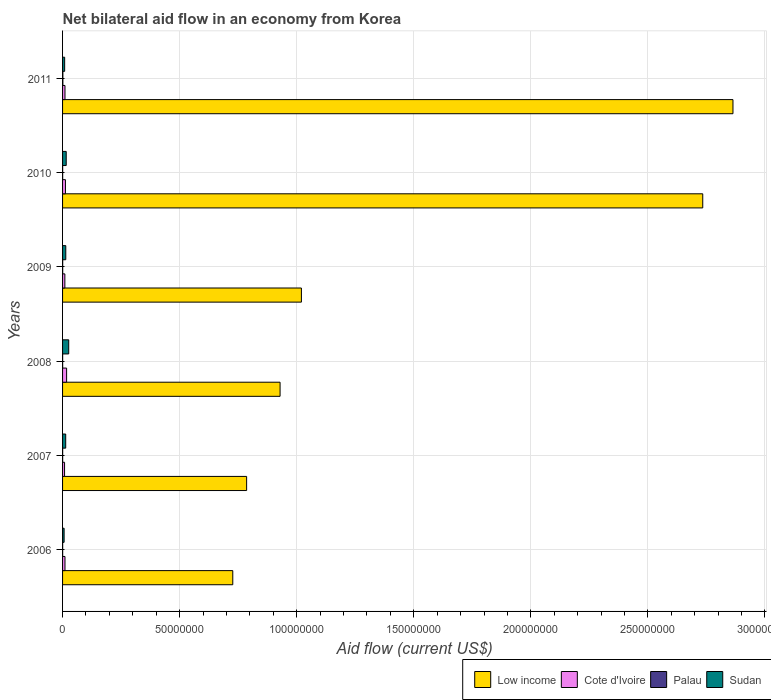How many groups of bars are there?
Make the answer very short. 6. Are the number of bars per tick equal to the number of legend labels?
Your answer should be very brief. Yes. Are the number of bars on each tick of the Y-axis equal?
Offer a very short reply. Yes. How many bars are there on the 6th tick from the top?
Your answer should be very brief. 4. How many bars are there on the 4th tick from the bottom?
Offer a very short reply. 4. In how many cases, is the number of bars for a given year not equal to the number of legend labels?
Provide a succinct answer. 0. What is the net bilateral aid flow in Cote d'Ivoire in 2006?
Provide a succinct answer. 1.03e+06. Across all years, what is the maximum net bilateral aid flow in Sudan?
Your answer should be very brief. 2.63e+06. In which year was the net bilateral aid flow in Palau maximum?
Your response must be concise. 2011. What is the total net bilateral aid flow in Sudan in the graph?
Keep it short and to the point. 8.45e+06. What is the average net bilateral aid flow in Low income per year?
Make the answer very short. 1.51e+08. In the year 2008, what is the difference between the net bilateral aid flow in Cote d'Ivoire and net bilateral aid flow in Low income?
Make the answer very short. -9.12e+07. In how many years, is the net bilateral aid flow in Palau greater than 40000000 US$?
Your response must be concise. 0. What is the ratio of the net bilateral aid flow in Palau in 2006 to that in 2011?
Your response must be concise. 0.31. Is the net bilateral aid flow in Sudan in 2008 less than that in 2011?
Your response must be concise. No. What is the difference between the highest and the lowest net bilateral aid flow in Palau?
Give a very brief answer. 1.00e+05. Is the sum of the net bilateral aid flow in Sudan in 2009 and 2010 greater than the maximum net bilateral aid flow in Low income across all years?
Ensure brevity in your answer.  No. Is it the case that in every year, the sum of the net bilateral aid flow in Cote d'Ivoire and net bilateral aid flow in Low income is greater than the sum of net bilateral aid flow in Palau and net bilateral aid flow in Sudan?
Ensure brevity in your answer.  No. What does the 3rd bar from the top in 2009 represents?
Offer a very short reply. Cote d'Ivoire. What does the 1st bar from the bottom in 2011 represents?
Your answer should be very brief. Low income. Is it the case that in every year, the sum of the net bilateral aid flow in Palau and net bilateral aid flow in Low income is greater than the net bilateral aid flow in Sudan?
Make the answer very short. Yes. What is the difference between two consecutive major ticks on the X-axis?
Provide a short and direct response. 5.00e+07. How many legend labels are there?
Offer a terse response. 4. What is the title of the graph?
Your response must be concise. Net bilateral aid flow in an economy from Korea. Does "Namibia" appear as one of the legend labels in the graph?
Provide a short and direct response. No. What is the label or title of the X-axis?
Offer a terse response. Aid flow (current US$). What is the label or title of the Y-axis?
Offer a very short reply. Years. What is the Aid flow (current US$) of Low income in 2006?
Offer a very short reply. 7.27e+07. What is the Aid flow (current US$) in Cote d'Ivoire in 2006?
Keep it short and to the point. 1.03e+06. What is the Aid flow (current US$) of Palau in 2006?
Offer a very short reply. 4.00e+04. What is the Aid flow (current US$) of Sudan in 2006?
Offer a terse response. 6.60e+05. What is the Aid flow (current US$) of Low income in 2007?
Your answer should be very brief. 7.86e+07. What is the Aid flow (current US$) of Cote d'Ivoire in 2007?
Your answer should be compact. 8.50e+05. What is the Aid flow (current US$) of Palau in 2007?
Give a very brief answer. 4.00e+04. What is the Aid flow (current US$) of Sudan in 2007?
Give a very brief answer. 1.34e+06. What is the Aid flow (current US$) in Low income in 2008?
Your answer should be very brief. 9.29e+07. What is the Aid flow (current US$) of Cote d'Ivoire in 2008?
Your answer should be compact. 1.73e+06. What is the Aid flow (current US$) in Palau in 2008?
Give a very brief answer. 3.00e+04. What is the Aid flow (current US$) of Sudan in 2008?
Offer a terse response. 2.63e+06. What is the Aid flow (current US$) of Low income in 2009?
Ensure brevity in your answer.  1.02e+08. What is the Aid flow (current US$) of Cote d'Ivoire in 2009?
Your response must be concise. 9.80e+05. What is the Aid flow (current US$) in Palau in 2009?
Keep it short and to the point. 5.00e+04. What is the Aid flow (current US$) in Sudan in 2009?
Make the answer very short. 1.37e+06. What is the Aid flow (current US$) in Low income in 2010?
Your answer should be compact. 2.73e+08. What is the Aid flow (current US$) of Cote d'Ivoire in 2010?
Make the answer very short. 1.23e+06. What is the Aid flow (current US$) in Palau in 2010?
Your response must be concise. 4.00e+04. What is the Aid flow (current US$) of Sudan in 2010?
Offer a terse response. 1.56e+06. What is the Aid flow (current US$) in Low income in 2011?
Offer a very short reply. 2.86e+08. What is the Aid flow (current US$) of Cote d'Ivoire in 2011?
Your answer should be compact. 1.03e+06. What is the Aid flow (current US$) in Sudan in 2011?
Keep it short and to the point. 8.90e+05. Across all years, what is the maximum Aid flow (current US$) in Low income?
Keep it short and to the point. 2.86e+08. Across all years, what is the maximum Aid flow (current US$) of Cote d'Ivoire?
Your answer should be very brief. 1.73e+06. Across all years, what is the maximum Aid flow (current US$) in Sudan?
Provide a succinct answer. 2.63e+06. Across all years, what is the minimum Aid flow (current US$) of Low income?
Your response must be concise. 7.27e+07. Across all years, what is the minimum Aid flow (current US$) of Cote d'Ivoire?
Give a very brief answer. 8.50e+05. Across all years, what is the minimum Aid flow (current US$) of Sudan?
Provide a short and direct response. 6.60e+05. What is the total Aid flow (current US$) of Low income in the graph?
Your answer should be compact. 9.06e+08. What is the total Aid flow (current US$) in Cote d'Ivoire in the graph?
Provide a short and direct response. 6.85e+06. What is the total Aid flow (current US$) in Palau in the graph?
Provide a short and direct response. 3.30e+05. What is the total Aid flow (current US$) in Sudan in the graph?
Ensure brevity in your answer.  8.45e+06. What is the difference between the Aid flow (current US$) of Low income in 2006 and that in 2007?
Give a very brief answer. -5.91e+06. What is the difference between the Aid flow (current US$) of Cote d'Ivoire in 2006 and that in 2007?
Offer a terse response. 1.80e+05. What is the difference between the Aid flow (current US$) in Palau in 2006 and that in 2007?
Give a very brief answer. 0. What is the difference between the Aid flow (current US$) in Sudan in 2006 and that in 2007?
Provide a succinct answer. -6.80e+05. What is the difference between the Aid flow (current US$) of Low income in 2006 and that in 2008?
Your answer should be compact. -2.02e+07. What is the difference between the Aid flow (current US$) in Cote d'Ivoire in 2006 and that in 2008?
Make the answer very short. -7.00e+05. What is the difference between the Aid flow (current US$) in Sudan in 2006 and that in 2008?
Your response must be concise. -1.97e+06. What is the difference between the Aid flow (current US$) of Low income in 2006 and that in 2009?
Your answer should be compact. -2.93e+07. What is the difference between the Aid flow (current US$) of Palau in 2006 and that in 2009?
Offer a terse response. -10000. What is the difference between the Aid flow (current US$) of Sudan in 2006 and that in 2009?
Make the answer very short. -7.10e+05. What is the difference between the Aid flow (current US$) of Low income in 2006 and that in 2010?
Keep it short and to the point. -2.01e+08. What is the difference between the Aid flow (current US$) of Cote d'Ivoire in 2006 and that in 2010?
Your answer should be compact. -2.00e+05. What is the difference between the Aid flow (current US$) of Palau in 2006 and that in 2010?
Provide a succinct answer. 0. What is the difference between the Aid flow (current US$) of Sudan in 2006 and that in 2010?
Your answer should be compact. -9.00e+05. What is the difference between the Aid flow (current US$) of Low income in 2006 and that in 2011?
Make the answer very short. -2.14e+08. What is the difference between the Aid flow (current US$) of Palau in 2006 and that in 2011?
Make the answer very short. -9.00e+04. What is the difference between the Aid flow (current US$) in Low income in 2007 and that in 2008?
Make the answer very short. -1.43e+07. What is the difference between the Aid flow (current US$) of Cote d'Ivoire in 2007 and that in 2008?
Ensure brevity in your answer.  -8.80e+05. What is the difference between the Aid flow (current US$) in Palau in 2007 and that in 2008?
Your answer should be compact. 10000. What is the difference between the Aid flow (current US$) in Sudan in 2007 and that in 2008?
Your answer should be very brief. -1.29e+06. What is the difference between the Aid flow (current US$) in Low income in 2007 and that in 2009?
Offer a very short reply. -2.34e+07. What is the difference between the Aid flow (current US$) in Low income in 2007 and that in 2010?
Ensure brevity in your answer.  -1.95e+08. What is the difference between the Aid flow (current US$) in Cote d'Ivoire in 2007 and that in 2010?
Keep it short and to the point. -3.80e+05. What is the difference between the Aid flow (current US$) in Low income in 2007 and that in 2011?
Make the answer very short. -2.08e+08. What is the difference between the Aid flow (current US$) in Palau in 2007 and that in 2011?
Provide a short and direct response. -9.00e+04. What is the difference between the Aid flow (current US$) of Low income in 2008 and that in 2009?
Offer a terse response. -9.11e+06. What is the difference between the Aid flow (current US$) of Cote d'Ivoire in 2008 and that in 2009?
Offer a terse response. 7.50e+05. What is the difference between the Aid flow (current US$) of Palau in 2008 and that in 2009?
Offer a very short reply. -2.00e+04. What is the difference between the Aid flow (current US$) in Sudan in 2008 and that in 2009?
Offer a terse response. 1.26e+06. What is the difference between the Aid flow (current US$) of Low income in 2008 and that in 2010?
Keep it short and to the point. -1.81e+08. What is the difference between the Aid flow (current US$) in Palau in 2008 and that in 2010?
Your response must be concise. -10000. What is the difference between the Aid flow (current US$) of Sudan in 2008 and that in 2010?
Give a very brief answer. 1.07e+06. What is the difference between the Aid flow (current US$) of Low income in 2008 and that in 2011?
Keep it short and to the point. -1.93e+08. What is the difference between the Aid flow (current US$) in Sudan in 2008 and that in 2011?
Give a very brief answer. 1.74e+06. What is the difference between the Aid flow (current US$) of Low income in 2009 and that in 2010?
Make the answer very short. -1.71e+08. What is the difference between the Aid flow (current US$) of Sudan in 2009 and that in 2010?
Keep it short and to the point. -1.90e+05. What is the difference between the Aid flow (current US$) of Low income in 2009 and that in 2011?
Your response must be concise. -1.84e+08. What is the difference between the Aid flow (current US$) in Palau in 2009 and that in 2011?
Provide a succinct answer. -8.00e+04. What is the difference between the Aid flow (current US$) in Low income in 2010 and that in 2011?
Your answer should be compact. -1.29e+07. What is the difference between the Aid flow (current US$) of Cote d'Ivoire in 2010 and that in 2011?
Ensure brevity in your answer.  2.00e+05. What is the difference between the Aid flow (current US$) of Palau in 2010 and that in 2011?
Keep it short and to the point. -9.00e+04. What is the difference between the Aid flow (current US$) of Sudan in 2010 and that in 2011?
Make the answer very short. 6.70e+05. What is the difference between the Aid flow (current US$) of Low income in 2006 and the Aid flow (current US$) of Cote d'Ivoire in 2007?
Give a very brief answer. 7.18e+07. What is the difference between the Aid flow (current US$) of Low income in 2006 and the Aid flow (current US$) of Palau in 2007?
Provide a succinct answer. 7.27e+07. What is the difference between the Aid flow (current US$) of Low income in 2006 and the Aid flow (current US$) of Sudan in 2007?
Ensure brevity in your answer.  7.14e+07. What is the difference between the Aid flow (current US$) of Cote d'Ivoire in 2006 and the Aid flow (current US$) of Palau in 2007?
Provide a short and direct response. 9.90e+05. What is the difference between the Aid flow (current US$) in Cote d'Ivoire in 2006 and the Aid flow (current US$) in Sudan in 2007?
Give a very brief answer. -3.10e+05. What is the difference between the Aid flow (current US$) in Palau in 2006 and the Aid flow (current US$) in Sudan in 2007?
Keep it short and to the point. -1.30e+06. What is the difference between the Aid flow (current US$) of Low income in 2006 and the Aid flow (current US$) of Cote d'Ivoire in 2008?
Provide a short and direct response. 7.10e+07. What is the difference between the Aid flow (current US$) of Low income in 2006 and the Aid flow (current US$) of Palau in 2008?
Your answer should be very brief. 7.27e+07. What is the difference between the Aid flow (current US$) in Low income in 2006 and the Aid flow (current US$) in Sudan in 2008?
Your answer should be very brief. 7.01e+07. What is the difference between the Aid flow (current US$) in Cote d'Ivoire in 2006 and the Aid flow (current US$) in Sudan in 2008?
Your answer should be very brief. -1.60e+06. What is the difference between the Aid flow (current US$) of Palau in 2006 and the Aid flow (current US$) of Sudan in 2008?
Provide a short and direct response. -2.59e+06. What is the difference between the Aid flow (current US$) of Low income in 2006 and the Aid flow (current US$) of Cote d'Ivoire in 2009?
Provide a short and direct response. 7.17e+07. What is the difference between the Aid flow (current US$) in Low income in 2006 and the Aid flow (current US$) in Palau in 2009?
Keep it short and to the point. 7.26e+07. What is the difference between the Aid flow (current US$) in Low income in 2006 and the Aid flow (current US$) in Sudan in 2009?
Make the answer very short. 7.13e+07. What is the difference between the Aid flow (current US$) of Cote d'Ivoire in 2006 and the Aid flow (current US$) of Palau in 2009?
Your response must be concise. 9.80e+05. What is the difference between the Aid flow (current US$) in Cote d'Ivoire in 2006 and the Aid flow (current US$) in Sudan in 2009?
Give a very brief answer. -3.40e+05. What is the difference between the Aid flow (current US$) of Palau in 2006 and the Aid flow (current US$) of Sudan in 2009?
Offer a very short reply. -1.33e+06. What is the difference between the Aid flow (current US$) of Low income in 2006 and the Aid flow (current US$) of Cote d'Ivoire in 2010?
Provide a succinct answer. 7.15e+07. What is the difference between the Aid flow (current US$) of Low income in 2006 and the Aid flow (current US$) of Palau in 2010?
Your answer should be compact. 7.27e+07. What is the difference between the Aid flow (current US$) of Low income in 2006 and the Aid flow (current US$) of Sudan in 2010?
Provide a succinct answer. 7.11e+07. What is the difference between the Aid flow (current US$) of Cote d'Ivoire in 2006 and the Aid flow (current US$) of Palau in 2010?
Make the answer very short. 9.90e+05. What is the difference between the Aid flow (current US$) of Cote d'Ivoire in 2006 and the Aid flow (current US$) of Sudan in 2010?
Ensure brevity in your answer.  -5.30e+05. What is the difference between the Aid flow (current US$) of Palau in 2006 and the Aid flow (current US$) of Sudan in 2010?
Your answer should be compact. -1.52e+06. What is the difference between the Aid flow (current US$) of Low income in 2006 and the Aid flow (current US$) of Cote d'Ivoire in 2011?
Your answer should be very brief. 7.17e+07. What is the difference between the Aid flow (current US$) of Low income in 2006 and the Aid flow (current US$) of Palau in 2011?
Keep it short and to the point. 7.26e+07. What is the difference between the Aid flow (current US$) in Low income in 2006 and the Aid flow (current US$) in Sudan in 2011?
Ensure brevity in your answer.  7.18e+07. What is the difference between the Aid flow (current US$) in Cote d'Ivoire in 2006 and the Aid flow (current US$) in Palau in 2011?
Your answer should be very brief. 9.00e+05. What is the difference between the Aid flow (current US$) of Palau in 2006 and the Aid flow (current US$) of Sudan in 2011?
Keep it short and to the point. -8.50e+05. What is the difference between the Aid flow (current US$) in Low income in 2007 and the Aid flow (current US$) in Cote d'Ivoire in 2008?
Your response must be concise. 7.69e+07. What is the difference between the Aid flow (current US$) in Low income in 2007 and the Aid flow (current US$) in Palau in 2008?
Offer a terse response. 7.86e+07. What is the difference between the Aid flow (current US$) of Low income in 2007 and the Aid flow (current US$) of Sudan in 2008?
Your response must be concise. 7.60e+07. What is the difference between the Aid flow (current US$) of Cote d'Ivoire in 2007 and the Aid flow (current US$) of Palau in 2008?
Offer a very short reply. 8.20e+05. What is the difference between the Aid flow (current US$) in Cote d'Ivoire in 2007 and the Aid flow (current US$) in Sudan in 2008?
Your answer should be compact. -1.78e+06. What is the difference between the Aid flow (current US$) of Palau in 2007 and the Aid flow (current US$) of Sudan in 2008?
Keep it short and to the point. -2.59e+06. What is the difference between the Aid flow (current US$) in Low income in 2007 and the Aid flow (current US$) in Cote d'Ivoire in 2009?
Provide a short and direct response. 7.76e+07. What is the difference between the Aid flow (current US$) of Low income in 2007 and the Aid flow (current US$) of Palau in 2009?
Provide a succinct answer. 7.86e+07. What is the difference between the Aid flow (current US$) in Low income in 2007 and the Aid flow (current US$) in Sudan in 2009?
Your response must be concise. 7.72e+07. What is the difference between the Aid flow (current US$) in Cote d'Ivoire in 2007 and the Aid flow (current US$) in Palau in 2009?
Your response must be concise. 8.00e+05. What is the difference between the Aid flow (current US$) of Cote d'Ivoire in 2007 and the Aid flow (current US$) of Sudan in 2009?
Provide a short and direct response. -5.20e+05. What is the difference between the Aid flow (current US$) of Palau in 2007 and the Aid flow (current US$) of Sudan in 2009?
Make the answer very short. -1.33e+06. What is the difference between the Aid flow (current US$) in Low income in 2007 and the Aid flow (current US$) in Cote d'Ivoire in 2010?
Offer a terse response. 7.74e+07. What is the difference between the Aid flow (current US$) of Low income in 2007 and the Aid flow (current US$) of Palau in 2010?
Ensure brevity in your answer.  7.86e+07. What is the difference between the Aid flow (current US$) of Low income in 2007 and the Aid flow (current US$) of Sudan in 2010?
Offer a very short reply. 7.70e+07. What is the difference between the Aid flow (current US$) in Cote d'Ivoire in 2007 and the Aid flow (current US$) in Palau in 2010?
Provide a short and direct response. 8.10e+05. What is the difference between the Aid flow (current US$) of Cote d'Ivoire in 2007 and the Aid flow (current US$) of Sudan in 2010?
Provide a short and direct response. -7.10e+05. What is the difference between the Aid flow (current US$) in Palau in 2007 and the Aid flow (current US$) in Sudan in 2010?
Provide a short and direct response. -1.52e+06. What is the difference between the Aid flow (current US$) of Low income in 2007 and the Aid flow (current US$) of Cote d'Ivoire in 2011?
Offer a very short reply. 7.76e+07. What is the difference between the Aid flow (current US$) of Low income in 2007 and the Aid flow (current US$) of Palau in 2011?
Give a very brief answer. 7.85e+07. What is the difference between the Aid flow (current US$) in Low income in 2007 and the Aid flow (current US$) in Sudan in 2011?
Give a very brief answer. 7.77e+07. What is the difference between the Aid flow (current US$) of Cote d'Ivoire in 2007 and the Aid flow (current US$) of Palau in 2011?
Offer a terse response. 7.20e+05. What is the difference between the Aid flow (current US$) in Palau in 2007 and the Aid flow (current US$) in Sudan in 2011?
Keep it short and to the point. -8.50e+05. What is the difference between the Aid flow (current US$) in Low income in 2008 and the Aid flow (current US$) in Cote d'Ivoire in 2009?
Your response must be concise. 9.19e+07. What is the difference between the Aid flow (current US$) of Low income in 2008 and the Aid flow (current US$) of Palau in 2009?
Your response must be concise. 9.28e+07. What is the difference between the Aid flow (current US$) of Low income in 2008 and the Aid flow (current US$) of Sudan in 2009?
Provide a short and direct response. 9.15e+07. What is the difference between the Aid flow (current US$) of Cote d'Ivoire in 2008 and the Aid flow (current US$) of Palau in 2009?
Offer a very short reply. 1.68e+06. What is the difference between the Aid flow (current US$) of Cote d'Ivoire in 2008 and the Aid flow (current US$) of Sudan in 2009?
Your response must be concise. 3.60e+05. What is the difference between the Aid flow (current US$) of Palau in 2008 and the Aid flow (current US$) of Sudan in 2009?
Offer a very short reply. -1.34e+06. What is the difference between the Aid flow (current US$) in Low income in 2008 and the Aid flow (current US$) in Cote d'Ivoire in 2010?
Your answer should be compact. 9.17e+07. What is the difference between the Aid flow (current US$) in Low income in 2008 and the Aid flow (current US$) in Palau in 2010?
Your answer should be very brief. 9.29e+07. What is the difference between the Aid flow (current US$) of Low income in 2008 and the Aid flow (current US$) of Sudan in 2010?
Give a very brief answer. 9.13e+07. What is the difference between the Aid flow (current US$) in Cote d'Ivoire in 2008 and the Aid flow (current US$) in Palau in 2010?
Make the answer very short. 1.69e+06. What is the difference between the Aid flow (current US$) in Palau in 2008 and the Aid flow (current US$) in Sudan in 2010?
Make the answer very short. -1.53e+06. What is the difference between the Aid flow (current US$) in Low income in 2008 and the Aid flow (current US$) in Cote d'Ivoire in 2011?
Provide a short and direct response. 9.19e+07. What is the difference between the Aid flow (current US$) of Low income in 2008 and the Aid flow (current US$) of Palau in 2011?
Ensure brevity in your answer.  9.28e+07. What is the difference between the Aid flow (current US$) of Low income in 2008 and the Aid flow (current US$) of Sudan in 2011?
Offer a very short reply. 9.20e+07. What is the difference between the Aid flow (current US$) of Cote d'Ivoire in 2008 and the Aid flow (current US$) of Palau in 2011?
Offer a terse response. 1.60e+06. What is the difference between the Aid flow (current US$) of Cote d'Ivoire in 2008 and the Aid flow (current US$) of Sudan in 2011?
Give a very brief answer. 8.40e+05. What is the difference between the Aid flow (current US$) of Palau in 2008 and the Aid flow (current US$) of Sudan in 2011?
Keep it short and to the point. -8.60e+05. What is the difference between the Aid flow (current US$) in Low income in 2009 and the Aid flow (current US$) in Cote d'Ivoire in 2010?
Keep it short and to the point. 1.01e+08. What is the difference between the Aid flow (current US$) in Low income in 2009 and the Aid flow (current US$) in Palau in 2010?
Your answer should be very brief. 1.02e+08. What is the difference between the Aid flow (current US$) of Low income in 2009 and the Aid flow (current US$) of Sudan in 2010?
Your answer should be compact. 1.00e+08. What is the difference between the Aid flow (current US$) of Cote d'Ivoire in 2009 and the Aid flow (current US$) of Palau in 2010?
Provide a short and direct response. 9.40e+05. What is the difference between the Aid flow (current US$) of Cote d'Ivoire in 2009 and the Aid flow (current US$) of Sudan in 2010?
Make the answer very short. -5.80e+05. What is the difference between the Aid flow (current US$) of Palau in 2009 and the Aid flow (current US$) of Sudan in 2010?
Offer a terse response. -1.51e+06. What is the difference between the Aid flow (current US$) in Low income in 2009 and the Aid flow (current US$) in Cote d'Ivoire in 2011?
Your response must be concise. 1.01e+08. What is the difference between the Aid flow (current US$) in Low income in 2009 and the Aid flow (current US$) in Palau in 2011?
Your answer should be very brief. 1.02e+08. What is the difference between the Aid flow (current US$) in Low income in 2009 and the Aid flow (current US$) in Sudan in 2011?
Offer a very short reply. 1.01e+08. What is the difference between the Aid flow (current US$) in Cote d'Ivoire in 2009 and the Aid flow (current US$) in Palau in 2011?
Make the answer very short. 8.50e+05. What is the difference between the Aid flow (current US$) in Palau in 2009 and the Aid flow (current US$) in Sudan in 2011?
Keep it short and to the point. -8.40e+05. What is the difference between the Aid flow (current US$) in Low income in 2010 and the Aid flow (current US$) in Cote d'Ivoire in 2011?
Your response must be concise. 2.72e+08. What is the difference between the Aid flow (current US$) of Low income in 2010 and the Aid flow (current US$) of Palau in 2011?
Keep it short and to the point. 2.73e+08. What is the difference between the Aid flow (current US$) in Low income in 2010 and the Aid flow (current US$) in Sudan in 2011?
Keep it short and to the point. 2.73e+08. What is the difference between the Aid flow (current US$) of Cote d'Ivoire in 2010 and the Aid flow (current US$) of Palau in 2011?
Ensure brevity in your answer.  1.10e+06. What is the difference between the Aid flow (current US$) in Palau in 2010 and the Aid flow (current US$) in Sudan in 2011?
Provide a succinct answer. -8.50e+05. What is the average Aid flow (current US$) in Low income per year?
Keep it short and to the point. 1.51e+08. What is the average Aid flow (current US$) in Cote d'Ivoire per year?
Provide a short and direct response. 1.14e+06. What is the average Aid flow (current US$) in Palau per year?
Make the answer very short. 5.50e+04. What is the average Aid flow (current US$) of Sudan per year?
Your answer should be compact. 1.41e+06. In the year 2006, what is the difference between the Aid flow (current US$) of Low income and Aid flow (current US$) of Cote d'Ivoire?
Offer a very short reply. 7.17e+07. In the year 2006, what is the difference between the Aid flow (current US$) in Low income and Aid flow (current US$) in Palau?
Give a very brief answer. 7.27e+07. In the year 2006, what is the difference between the Aid flow (current US$) in Low income and Aid flow (current US$) in Sudan?
Give a very brief answer. 7.20e+07. In the year 2006, what is the difference between the Aid flow (current US$) in Cote d'Ivoire and Aid flow (current US$) in Palau?
Make the answer very short. 9.90e+05. In the year 2006, what is the difference between the Aid flow (current US$) of Palau and Aid flow (current US$) of Sudan?
Your answer should be compact. -6.20e+05. In the year 2007, what is the difference between the Aid flow (current US$) of Low income and Aid flow (current US$) of Cote d'Ivoire?
Ensure brevity in your answer.  7.78e+07. In the year 2007, what is the difference between the Aid flow (current US$) of Low income and Aid flow (current US$) of Palau?
Offer a very short reply. 7.86e+07. In the year 2007, what is the difference between the Aid flow (current US$) in Low income and Aid flow (current US$) in Sudan?
Your response must be concise. 7.73e+07. In the year 2007, what is the difference between the Aid flow (current US$) of Cote d'Ivoire and Aid flow (current US$) of Palau?
Make the answer very short. 8.10e+05. In the year 2007, what is the difference between the Aid flow (current US$) of Cote d'Ivoire and Aid flow (current US$) of Sudan?
Provide a short and direct response. -4.90e+05. In the year 2007, what is the difference between the Aid flow (current US$) of Palau and Aid flow (current US$) of Sudan?
Keep it short and to the point. -1.30e+06. In the year 2008, what is the difference between the Aid flow (current US$) in Low income and Aid flow (current US$) in Cote d'Ivoire?
Keep it short and to the point. 9.12e+07. In the year 2008, what is the difference between the Aid flow (current US$) in Low income and Aid flow (current US$) in Palau?
Provide a short and direct response. 9.29e+07. In the year 2008, what is the difference between the Aid flow (current US$) in Low income and Aid flow (current US$) in Sudan?
Keep it short and to the point. 9.03e+07. In the year 2008, what is the difference between the Aid flow (current US$) of Cote d'Ivoire and Aid flow (current US$) of Palau?
Your answer should be very brief. 1.70e+06. In the year 2008, what is the difference between the Aid flow (current US$) of Cote d'Ivoire and Aid flow (current US$) of Sudan?
Your answer should be compact. -9.00e+05. In the year 2008, what is the difference between the Aid flow (current US$) of Palau and Aid flow (current US$) of Sudan?
Offer a very short reply. -2.60e+06. In the year 2009, what is the difference between the Aid flow (current US$) in Low income and Aid flow (current US$) in Cote d'Ivoire?
Ensure brevity in your answer.  1.01e+08. In the year 2009, what is the difference between the Aid flow (current US$) of Low income and Aid flow (current US$) of Palau?
Give a very brief answer. 1.02e+08. In the year 2009, what is the difference between the Aid flow (current US$) of Low income and Aid flow (current US$) of Sudan?
Keep it short and to the point. 1.01e+08. In the year 2009, what is the difference between the Aid flow (current US$) of Cote d'Ivoire and Aid flow (current US$) of Palau?
Make the answer very short. 9.30e+05. In the year 2009, what is the difference between the Aid flow (current US$) of Cote d'Ivoire and Aid flow (current US$) of Sudan?
Make the answer very short. -3.90e+05. In the year 2009, what is the difference between the Aid flow (current US$) of Palau and Aid flow (current US$) of Sudan?
Offer a very short reply. -1.32e+06. In the year 2010, what is the difference between the Aid flow (current US$) in Low income and Aid flow (current US$) in Cote d'Ivoire?
Your response must be concise. 2.72e+08. In the year 2010, what is the difference between the Aid flow (current US$) of Low income and Aid flow (current US$) of Palau?
Your response must be concise. 2.73e+08. In the year 2010, what is the difference between the Aid flow (current US$) of Low income and Aid flow (current US$) of Sudan?
Make the answer very short. 2.72e+08. In the year 2010, what is the difference between the Aid flow (current US$) of Cote d'Ivoire and Aid flow (current US$) of Palau?
Keep it short and to the point. 1.19e+06. In the year 2010, what is the difference between the Aid flow (current US$) of Cote d'Ivoire and Aid flow (current US$) of Sudan?
Offer a terse response. -3.30e+05. In the year 2010, what is the difference between the Aid flow (current US$) in Palau and Aid flow (current US$) in Sudan?
Your answer should be very brief. -1.52e+06. In the year 2011, what is the difference between the Aid flow (current US$) in Low income and Aid flow (current US$) in Cote d'Ivoire?
Make the answer very short. 2.85e+08. In the year 2011, what is the difference between the Aid flow (current US$) in Low income and Aid flow (current US$) in Palau?
Provide a succinct answer. 2.86e+08. In the year 2011, what is the difference between the Aid flow (current US$) of Low income and Aid flow (current US$) of Sudan?
Provide a short and direct response. 2.85e+08. In the year 2011, what is the difference between the Aid flow (current US$) of Cote d'Ivoire and Aid flow (current US$) of Palau?
Provide a succinct answer. 9.00e+05. In the year 2011, what is the difference between the Aid flow (current US$) of Palau and Aid flow (current US$) of Sudan?
Provide a succinct answer. -7.60e+05. What is the ratio of the Aid flow (current US$) in Low income in 2006 to that in 2007?
Your response must be concise. 0.92. What is the ratio of the Aid flow (current US$) in Cote d'Ivoire in 2006 to that in 2007?
Your answer should be compact. 1.21. What is the ratio of the Aid flow (current US$) in Sudan in 2006 to that in 2007?
Your response must be concise. 0.49. What is the ratio of the Aid flow (current US$) of Low income in 2006 to that in 2008?
Offer a very short reply. 0.78. What is the ratio of the Aid flow (current US$) of Cote d'Ivoire in 2006 to that in 2008?
Ensure brevity in your answer.  0.6. What is the ratio of the Aid flow (current US$) in Sudan in 2006 to that in 2008?
Your answer should be very brief. 0.25. What is the ratio of the Aid flow (current US$) of Low income in 2006 to that in 2009?
Your response must be concise. 0.71. What is the ratio of the Aid flow (current US$) of Cote d'Ivoire in 2006 to that in 2009?
Make the answer very short. 1.05. What is the ratio of the Aid flow (current US$) of Sudan in 2006 to that in 2009?
Ensure brevity in your answer.  0.48. What is the ratio of the Aid flow (current US$) in Low income in 2006 to that in 2010?
Ensure brevity in your answer.  0.27. What is the ratio of the Aid flow (current US$) of Cote d'Ivoire in 2006 to that in 2010?
Your response must be concise. 0.84. What is the ratio of the Aid flow (current US$) in Sudan in 2006 to that in 2010?
Provide a succinct answer. 0.42. What is the ratio of the Aid flow (current US$) of Low income in 2006 to that in 2011?
Ensure brevity in your answer.  0.25. What is the ratio of the Aid flow (current US$) of Cote d'Ivoire in 2006 to that in 2011?
Ensure brevity in your answer.  1. What is the ratio of the Aid flow (current US$) of Palau in 2006 to that in 2011?
Your answer should be very brief. 0.31. What is the ratio of the Aid flow (current US$) in Sudan in 2006 to that in 2011?
Your answer should be compact. 0.74. What is the ratio of the Aid flow (current US$) of Low income in 2007 to that in 2008?
Offer a terse response. 0.85. What is the ratio of the Aid flow (current US$) in Cote d'Ivoire in 2007 to that in 2008?
Make the answer very short. 0.49. What is the ratio of the Aid flow (current US$) in Sudan in 2007 to that in 2008?
Give a very brief answer. 0.51. What is the ratio of the Aid flow (current US$) in Low income in 2007 to that in 2009?
Offer a very short reply. 0.77. What is the ratio of the Aid flow (current US$) in Cote d'Ivoire in 2007 to that in 2009?
Offer a terse response. 0.87. What is the ratio of the Aid flow (current US$) of Sudan in 2007 to that in 2009?
Your answer should be very brief. 0.98. What is the ratio of the Aid flow (current US$) of Low income in 2007 to that in 2010?
Provide a succinct answer. 0.29. What is the ratio of the Aid flow (current US$) in Cote d'Ivoire in 2007 to that in 2010?
Your answer should be compact. 0.69. What is the ratio of the Aid flow (current US$) in Palau in 2007 to that in 2010?
Your answer should be very brief. 1. What is the ratio of the Aid flow (current US$) in Sudan in 2007 to that in 2010?
Offer a terse response. 0.86. What is the ratio of the Aid flow (current US$) in Low income in 2007 to that in 2011?
Give a very brief answer. 0.27. What is the ratio of the Aid flow (current US$) in Cote d'Ivoire in 2007 to that in 2011?
Provide a succinct answer. 0.83. What is the ratio of the Aid flow (current US$) of Palau in 2007 to that in 2011?
Make the answer very short. 0.31. What is the ratio of the Aid flow (current US$) of Sudan in 2007 to that in 2011?
Give a very brief answer. 1.51. What is the ratio of the Aid flow (current US$) in Low income in 2008 to that in 2009?
Offer a very short reply. 0.91. What is the ratio of the Aid flow (current US$) in Cote d'Ivoire in 2008 to that in 2009?
Offer a terse response. 1.77. What is the ratio of the Aid flow (current US$) of Palau in 2008 to that in 2009?
Ensure brevity in your answer.  0.6. What is the ratio of the Aid flow (current US$) of Sudan in 2008 to that in 2009?
Your answer should be very brief. 1.92. What is the ratio of the Aid flow (current US$) in Low income in 2008 to that in 2010?
Your answer should be very brief. 0.34. What is the ratio of the Aid flow (current US$) of Cote d'Ivoire in 2008 to that in 2010?
Offer a very short reply. 1.41. What is the ratio of the Aid flow (current US$) in Palau in 2008 to that in 2010?
Provide a short and direct response. 0.75. What is the ratio of the Aid flow (current US$) of Sudan in 2008 to that in 2010?
Keep it short and to the point. 1.69. What is the ratio of the Aid flow (current US$) of Low income in 2008 to that in 2011?
Your answer should be compact. 0.32. What is the ratio of the Aid flow (current US$) of Cote d'Ivoire in 2008 to that in 2011?
Provide a succinct answer. 1.68. What is the ratio of the Aid flow (current US$) of Palau in 2008 to that in 2011?
Offer a very short reply. 0.23. What is the ratio of the Aid flow (current US$) in Sudan in 2008 to that in 2011?
Provide a short and direct response. 2.96. What is the ratio of the Aid flow (current US$) of Low income in 2009 to that in 2010?
Provide a short and direct response. 0.37. What is the ratio of the Aid flow (current US$) in Cote d'Ivoire in 2009 to that in 2010?
Your answer should be very brief. 0.8. What is the ratio of the Aid flow (current US$) in Palau in 2009 to that in 2010?
Make the answer very short. 1.25. What is the ratio of the Aid flow (current US$) of Sudan in 2009 to that in 2010?
Give a very brief answer. 0.88. What is the ratio of the Aid flow (current US$) of Low income in 2009 to that in 2011?
Provide a short and direct response. 0.36. What is the ratio of the Aid flow (current US$) in Cote d'Ivoire in 2009 to that in 2011?
Ensure brevity in your answer.  0.95. What is the ratio of the Aid flow (current US$) in Palau in 2009 to that in 2011?
Your answer should be compact. 0.38. What is the ratio of the Aid flow (current US$) in Sudan in 2009 to that in 2011?
Provide a succinct answer. 1.54. What is the ratio of the Aid flow (current US$) of Low income in 2010 to that in 2011?
Your answer should be very brief. 0.95. What is the ratio of the Aid flow (current US$) in Cote d'Ivoire in 2010 to that in 2011?
Provide a succinct answer. 1.19. What is the ratio of the Aid flow (current US$) in Palau in 2010 to that in 2011?
Your answer should be very brief. 0.31. What is the ratio of the Aid flow (current US$) of Sudan in 2010 to that in 2011?
Make the answer very short. 1.75. What is the difference between the highest and the second highest Aid flow (current US$) of Low income?
Your answer should be compact. 1.29e+07. What is the difference between the highest and the second highest Aid flow (current US$) of Cote d'Ivoire?
Offer a very short reply. 5.00e+05. What is the difference between the highest and the second highest Aid flow (current US$) of Palau?
Your answer should be compact. 8.00e+04. What is the difference between the highest and the second highest Aid flow (current US$) in Sudan?
Ensure brevity in your answer.  1.07e+06. What is the difference between the highest and the lowest Aid flow (current US$) of Low income?
Offer a terse response. 2.14e+08. What is the difference between the highest and the lowest Aid flow (current US$) in Cote d'Ivoire?
Offer a terse response. 8.80e+05. What is the difference between the highest and the lowest Aid flow (current US$) in Palau?
Provide a succinct answer. 1.00e+05. What is the difference between the highest and the lowest Aid flow (current US$) of Sudan?
Provide a short and direct response. 1.97e+06. 